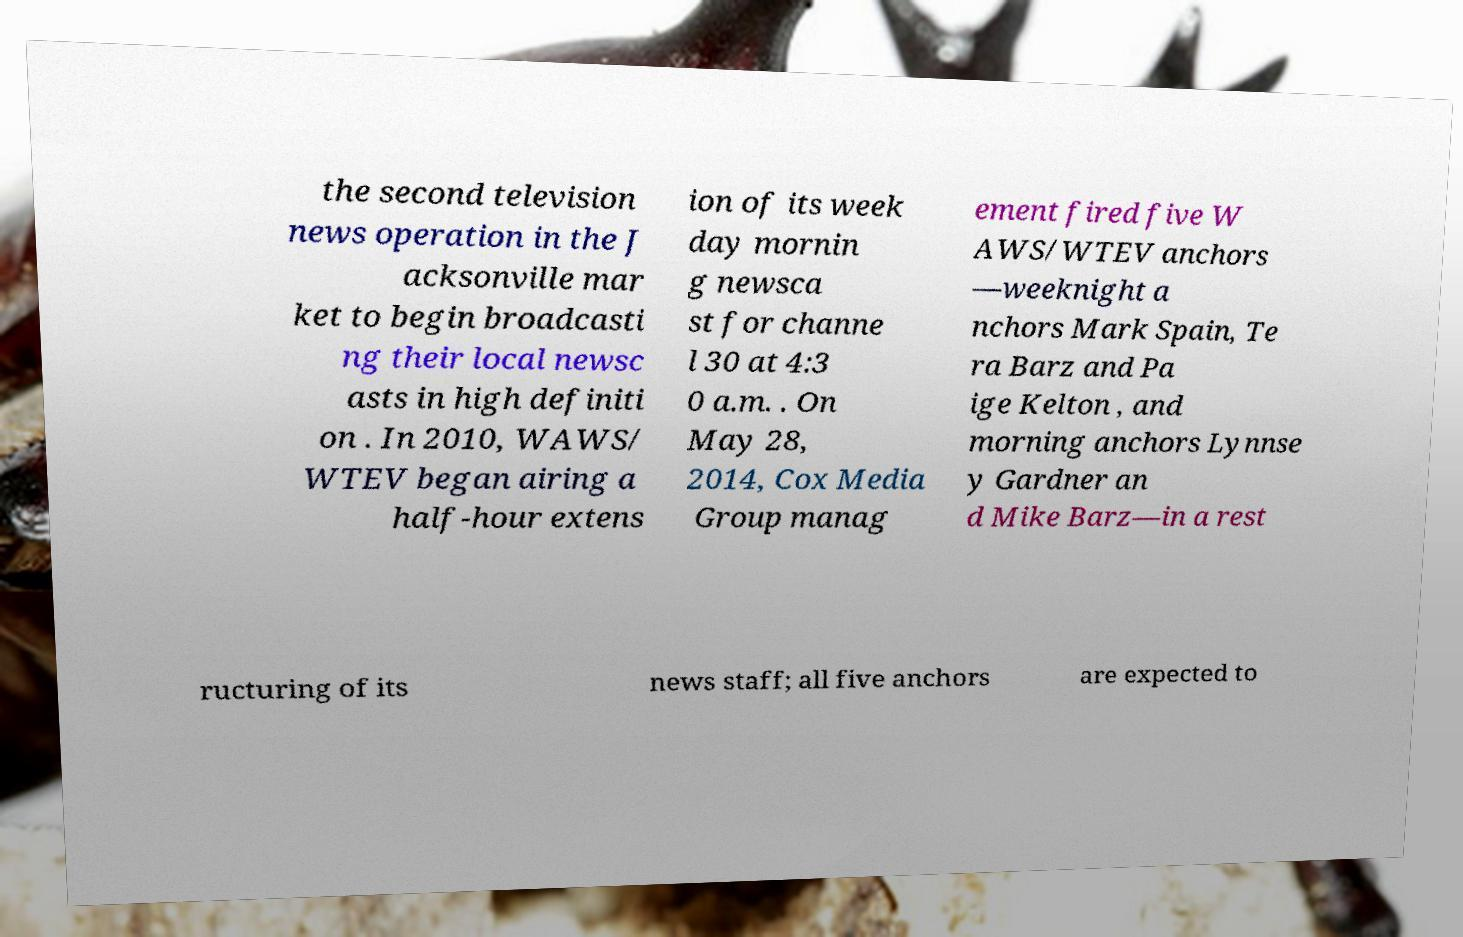Please read and relay the text visible in this image. What does it say? the second television news operation in the J acksonville mar ket to begin broadcasti ng their local newsc asts in high definiti on . In 2010, WAWS/ WTEV began airing a half-hour extens ion of its week day mornin g newsca st for channe l 30 at 4:3 0 a.m. . On May 28, 2014, Cox Media Group manag ement fired five W AWS/WTEV anchors —weeknight a nchors Mark Spain, Te ra Barz and Pa ige Kelton , and morning anchors Lynnse y Gardner an d Mike Barz—in a rest ructuring of its news staff; all five anchors are expected to 